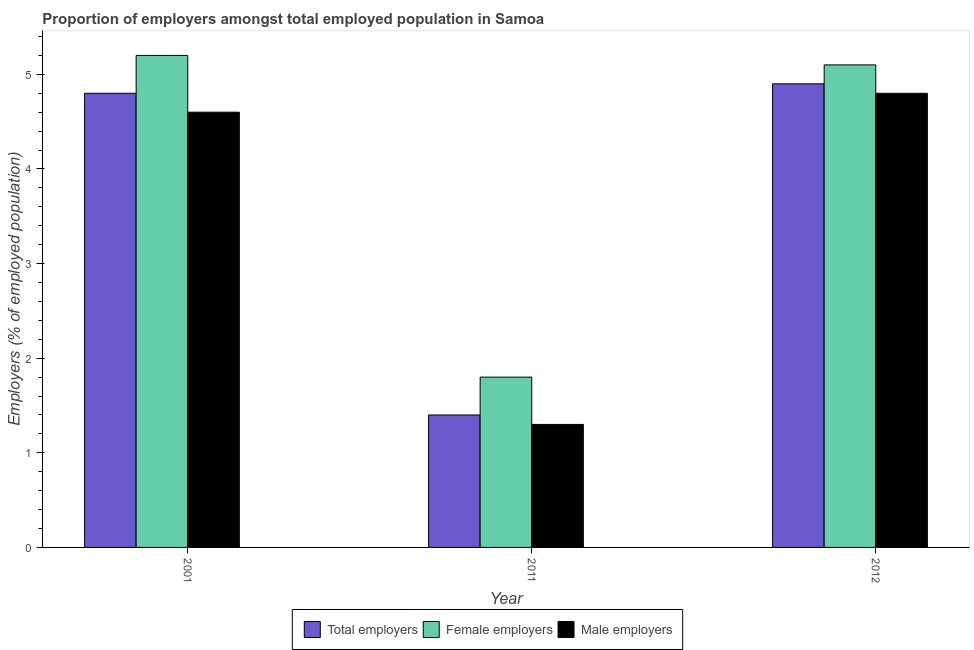Are the number of bars on each tick of the X-axis equal?
Your answer should be very brief. Yes. How many bars are there on the 2nd tick from the left?
Give a very brief answer. 3. How many bars are there on the 1st tick from the right?
Provide a succinct answer. 3. What is the percentage of female employers in 2001?
Keep it short and to the point. 5.2. Across all years, what is the maximum percentage of total employers?
Ensure brevity in your answer.  4.9. Across all years, what is the minimum percentage of male employers?
Offer a terse response. 1.3. In which year was the percentage of total employers maximum?
Your response must be concise. 2012. What is the total percentage of female employers in the graph?
Make the answer very short. 12.1. What is the difference between the percentage of male employers in 2001 and that in 2011?
Your answer should be very brief. 3.3. What is the difference between the percentage of total employers in 2011 and the percentage of female employers in 2001?
Provide a succinct answer. -3.4. What is the average percentage of female employers per year?
Provide a short and direct response. 4.03. What is the ratio of the percentage of female employers in 2011 to that in 2012?
Your answer should be compact. 0.35. Is the percentage of total employers in 2011 less than that in 2012?
Ensure brevity in your answer.  Yes. Is the difference between the percentage of male employers in 2011 and 2012 greater than the difference between the percentage of total employers in 2011 and 2012?
Offer a terse response. No. What is the difference between the highest and the second highest percentage of male employers?
Offer a terse response. 0.2. What is the difference between the highest and the lowest percentage of female employers?
Your answer should be compact. 3.4. In how many years, is the percentage of male employers greater than the average percentage of male employers taken over all years?
Provide a short and direct response. 2. Is the sum of the percentage of total employers in 2001 and 2011 greater than the maximum percentage of male employers across all years?
Give a very brief answer. Yes. What does the 2nd bar from the left in 2011 represents?
Your answer should be compact. Female employers. What does the 2nd bar from the right in 2012 represents?
Ensure brevity in your answer.  Female employers. How many bars are there?
Offer a very short reply. 9. Are all the bars in the graph horizontal?
Your response must be concise. No. How many years are there in the graph?
Offer a very short reply. 3. What is the difference between two consecutive major ticks on the Y-axis?
Your response must be concise. 1. Does the graph contain grids?
Provide a short and direct response. No. How many legend labels are there?
Make the answer very short. 3. How are the legend labels stacked?
Keep it short and to the point. Horizontal. What is the title of the graph?
Your response must be concise. Proportion of employers amongst total employed population in Samoa. Does "Ages 15-20" appear as one of the legend labels in the graph?
Give a very brief answer. No. What is the label or title of the X-axis?
Make the answer very short. Year. What is the label or title of the Y-axis?
Keep it short and to the point. Employers (% of employed population). What is the Employers (% of employed population) of Total employers in 2001?
Your response must be concise. 4.8. What is the Employers (% of employed population) of Female employers in 2001?
Your response must be concise. 5.2. What is the Employers (% of employed population) of Male employers in 2001?
Your response must be concise. 4.6. What is the Employers (% of employed population) in Total employers in 2011?
Keep it short and to the point. 1.4. What is the Employers (% of employed population) of Female employers in 2011?
Give a very brief answer. 1.8. What is the Employers (% of employed population) in Male employers in 2011?
Give a very brief answer. 1.3. What is the Employers (% of employed population) in Total employers in 2012?
Provide a short and direct response. 4.9. What is the Employers (% of employed population) of Female employers in 2012?
Your answer should be very brief. 5.1. What is the Employers (% of employed population) in Male employers in 2012?
Your answer should be very brief. 4.8. Across all years, what is the maximum Employers (% of employed population) of Total employers?
Give a very brief answer. 4.9. Across all years, what is the maximum Employers (% of employed population) of Female employers?
Provide a short and direct response. 5.2. Across all years, what is the maximum Employers (% of employed population) in Male employers?
Your answer should be very brief. 4.8. Across all years, what is the minimum Employers (% of employed population) of Total employers?
Your response must be concise. 1.4. Across all years, what is the minimum Employers (% of employed population) of Female employers?
Your response must be concise. 1.8. Across all years, what is the minimum Employers (% of employed population) of Male employers?
Offer a terse response. 1.3. What is the total Employers (% of employed population) of Male employers in the graph?
Your answer should be compact. 10.7. What is the difference between the Employers (% of employed population) in Total employers in 2001 and that in 2011?
Make the answer very short. 3.4. What is the difference between the Employers (% of employed population) in Female employers in 2001 and that in 2011?
Your answer should be compact. 3.4. What is the difference between the Employers (% of employed population) of Male employers in 2011 and that in 2012?
Give a very brief answer. -3.5. What is the difference between the Employers (% of employed population) of Total employers in 2001 and the Employers (% of employed population) of Female employers in 2011?
Your response must be concise. 3. What is the difference between the Employers (% of employed population) of Total employers in 2001 and the Employers (% of employed population) of Male employers in 2011?
Keep it short and to the point. 3.5. What is the difference between the Employers (% of employed population) of Female employers in 2001 and the Employers (% of employed population) of Male employers in 2011?
Your response must be concise. 3.9. What is the difference between the Employers (% of employed population) of Total employers in 2011 and the Employers (% of employed population) of Female employers in 2012?
Provide a short and direct response. -3.7. What is the difference between the Employers (% of employed population) of Total employers in 2011 and the Employers (% of employed population) of Male employers in 2012?
Provide a succinct answer. -3.4. What is the difference between the Employers (% of employed population) of Female employers in 2011 and the Employers (% of employed population) of Male employers in 2012?
Provide a short and direct response. -3. What is the average Employers (% of employed population) in Female employers per year?
Offer a very short reply. 4.03. What is the average Employers (% of employed population) of Male employers per year?
Give a very brief answer. 3.57. In the year 2001, what is the difference between the Employers (% of employed population) of Total employers and Employers (% of employed population) of Male employers?
Keep it short and to the point. 0.2. In the year 2001, what is the difference between the Employers (% of employed population) in Female employers and Employers (% of employed population) in Male employers?
Offer a very short reply. 0.6. In the year 2011, what is the difference between the Employers (% of employed population) in Total employers and Employers (% of employed population) in Male employers?
Offer a terse response. 0.1. In the year 2012, what is the difference between the Employers (% of employed population) in Total employers and Employers (% of employed population) in Female employers?
Your response must be concise. -0.2. In the year 2012, what is the difference between the Employers (% of employed population) of Total employers and Employers (% of employed population) of Male employers?
Offer a very short reply. 0.1. In the year 2012, what is the difference between the Employers (% of employed population) of Female employers and Employers (% of employed population) of Male employers?
Provide a succinct answer. 0.3. What is the ratio of the Employers (% of employed population) in Total employers in 2001 to that in 2011?
Give a very brief answer. 3.43. What is the ratio of the Employers (% of employed population) in Female employers in 2001 to that in 2011?
Provide a succinct answer. 2.89. What is the ratio of the Employers (% of employed population) of Male employers in 2001 to that in 2011?
Your answer should be compact. 3.54. What is the ratio of the Employers (% of employed population) in Total employers in 2001 to that in 2012?
Keep it short and to the point. 0.98. What is the ratio of the Employers (% of employed population) in Female employers in 2001 to that in 2012?
Your answer should be very brief. 1.02. What is the ratio of the Employers (% of employed population) in Male employers in 2001 to that in 2012?
Your answer should be compact. 0.96. What is the ratio of the Employers (% of employed population) of Total employers in 2011 to that in 2012?
Provide a short and direct response. 0.29. What is the ratio of the Employers (% of employed population) in Female employers in 2011 to that in 2012?
Provide a short and direct response. 0.35. What is the ratio of the Employers (% of employed population) in Male employers in 2011 to that in 2012?
Make the answer very short. 0.27. What is the difference between the highest and the second highest Employers (% of employed population) of Total employers?
Provide a succinct answer. 0.1. What is the difference between the highest and the second highest Employers (% of employed population) of Female employers?
Provide a short and direct response. 0.1. What is the difference between the highest and the lowest Employers (% of employed population) of Female employers?
Your answer should be compact. 3.4. What is the difference between the highest and the lowest Employers (% of employed population) of Male employers?
Keep it short and to the point. 3.5. 